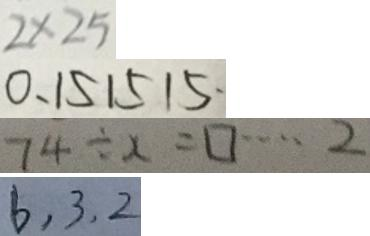<formula> <loc_0><loc_0><loc_500><loc_500>2 \times 2 5 
 0 . 1 5 1 5 1 5 \cdot 
 7 4 \div x = \square \cdots 2 
 6 . 3 . 2</formula> 